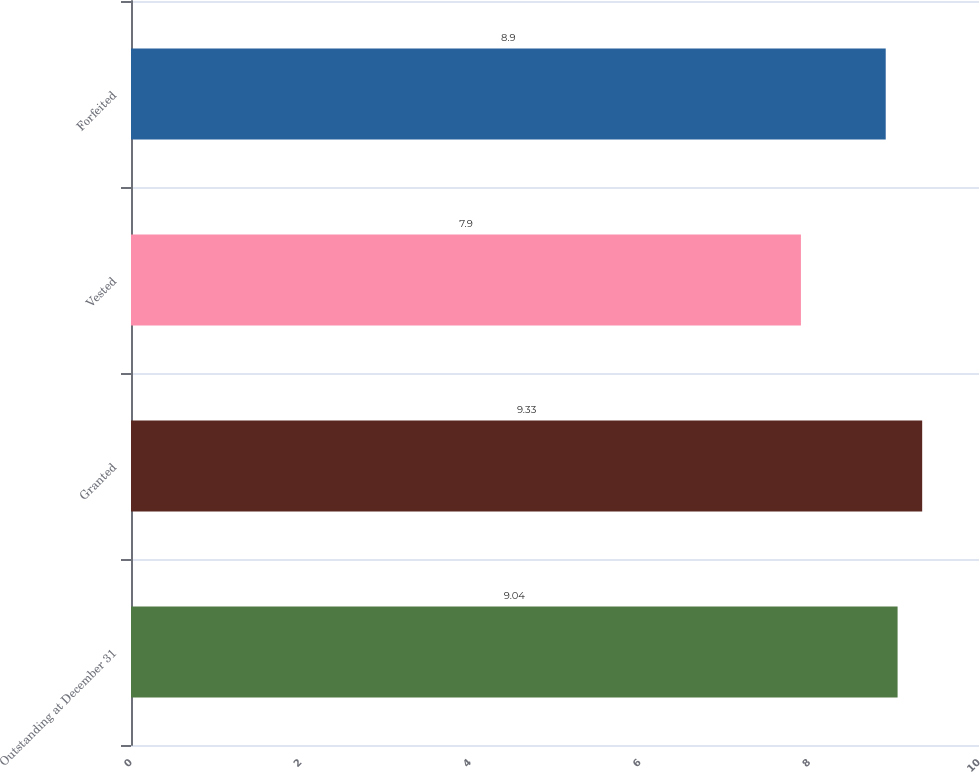Convert chart. <chart><loc_0><loc_0><loc_500><loc_500><bar_chart><fcel>Outstanding at December 31<fcel>Granted<fcel>Vested<fcel>Forfeited<nl><fcel>9.04<fcel>9.33<fcel>7.9<fcel>8.9<nl></chart> 